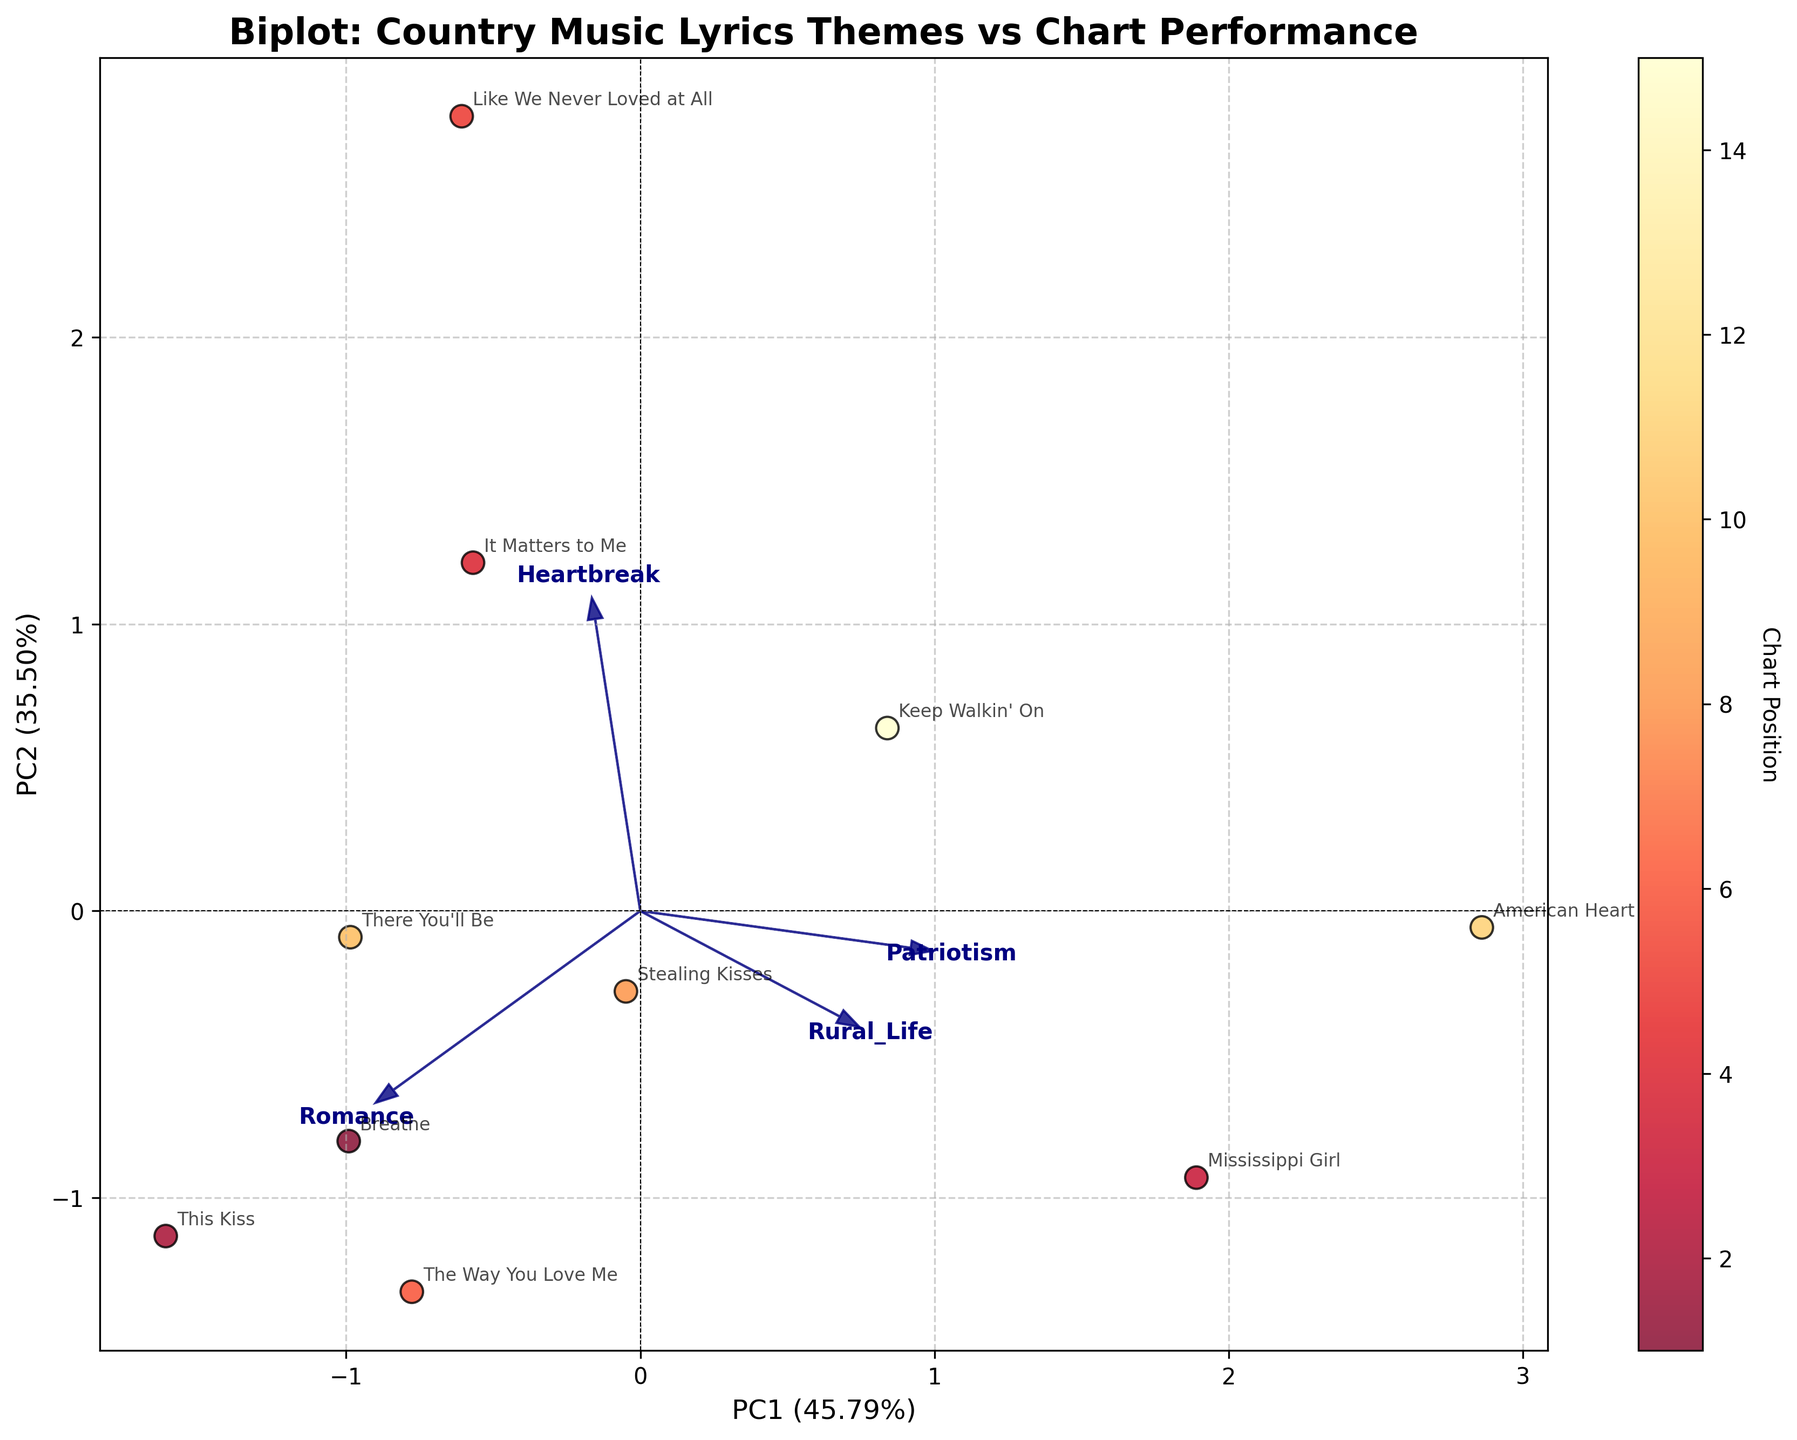what is the title of the plot? The title of the plot is typically found at the top of the figure. It is a text element that describes the overall purpose or content of the graph. In this case, the title reads "Biplot: Country Music Lyrics Themes vs Chart Performance".
Answer: Biplot: Country Music Lyrics Themes vs Chart Performance How are the data points color-coded? Data points in the figure are color-coded based on their chart position using a color gradient. In this case, the colors range from yellow to red, with lighter colors typically representing higher chart positions and darker colors representing lower chart positions.
Answer: By chart position Which two themes have the highest loading on PC1? To determine which themes have the highest loading on PC1, examine the arrows representing each theme. The themes with the longest arrows along the PC1 axis (x-axis) have the highest loadings. In this plot, "Romance" and "Heartbreak" have the most significant loadings on PC1.
Answer: Romance and Heartbreak Which song has the highest chart position and where is it located on the biplot? The song with the highest chart position is ranked 1. By looking at the data points, the song "Breathe" is the one that has the highest chart position. It is located towards the bottom-left of the biplot.
Answer: Breathe How does "Mississippi Girl" compare to "It Matters to Me" in terms of themes? To compare these two songs, analyze the directions of the arrows pointing towards their data points. "Mississippi Girl" (higher on Rural_Life and Patriotism) is positioned towards the top right, indicating stronger Rural_Life and Patriotism themes. "It Matters to Me" (higher on Heartbreak) is situated lower, showing a stronger Heartbreak theme.
Answer: "Mississippi Girl" has stronger Rural_Life and Patriotism themes, whereas "It Matters to Me" has a stronger Heartbreak theme Which song appears closest to the origin (0,0) on the biplot? The song closest to the origin (0,0) will have its data point near the center of the plot. By looking at the plot, "There You'll Be" seems to be the closest to the origin.
Answer: There You'll Be What is the relationship between Romance and Heartbreak themes and chart performance? By looking at the color gradient and the loadings of Romance and Heartbreak on the principal components, it appears that higher chart positions (lighter colors) are associated with higher Romance loadings and lower Heartbreak loadings.
Answer: Positive relation between Romance and chart performance, negative relation between Heartbreak and chart performance Identify one song with a high Patriotism theme and its chart performance. Look for the arrow labeled "Patriotism" and identify the song that lies in the direction of this arrow. "American Heart" is one such song, and its chart performance is indicated by its color, which is darker, corresponding to a lower chart position.
Answer: American Heart Which principal component explains more variance in the data, PC1 or PC2? Typically, the explained variance for each principal component is given in the axis labels. In this case, PC1 explains more variance because its explained variance percentage is higher than that of PC2.
Answer: PC1 